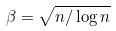<formula> <loc_0><loc_0><loc_500><loc_500>\beta = \sqrt { n / \log n }</formula> 